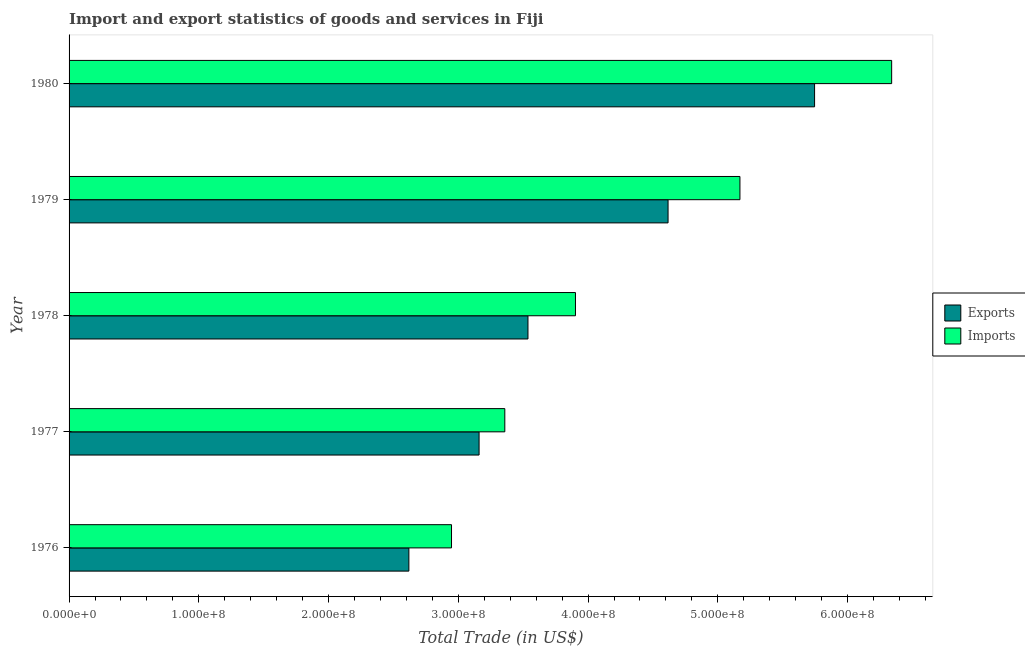How many different coloured bars are there?
Ensure brevity in your answer.  2. Are the number of bars on each tick of the Y-axis equal?
Provide a short and direct response. Yes. How many bars are there on the 5th tick from the top?
Your answer should be very brief. 2. How many bars are there on the 1st tick from the bottom?
Provide a short and direct response. 2. What is the label of the 3rd group of bars from the top?
Give a very brief answer. 1978. In how many cases, is the number of bars for a given year not equal to the number of legend labels?
Make the answer very short. 0. What is the imports of goods and services in 1978?
Your answer should be very brief. 3.90e+08. Across all years, what is the maximum export of goods and services?
Ensure brevity in your answer.  5.75e+08. Across all years, what is the minimum export of goods and services?
Offer a terse response. 2.62e+08. In which year was the export of goods and services maximum?
Offer a very short reply. 1980. In which year was the export of goods and services minimum?
Offer a very short reply. 1976. What is the total export of goods and services in the graph?
Provide a short and direct response. 1.97e+09. What is the difference between the export of goods and services in 1976 and that in 1980?
Your answer should be compact. -3.13e+08. What is the difference between the export of goods and services in 1979 and the imports of goods and services in 1980?
Give a very brief answer. -1.72e+08. What is the average export of goods and services per year?
Keep it short and to the point. 3.94e+08. In the year 1976, what is the difference between the export of goods and services and imports of goods and services?
Your answer should be very brief. -3.29e+07. What is the ratio of the export of goods and services in 1978 to that in 1980?
Your response must be concise. 0.62. Is the difference between the imports of goods and services in 1978 and 1979 greater than the difference between the export of goods and services in 1978 and 1979?
Your answer should be very brief. No. What is the difference between the highest and the second highest imports of goods and services?
Make the answer very short. 1.17e+08. What is the difference between the highest and the lowest export of goods and services?
Provide a succinct answer. 3.13e+08. In how many years, is the export of goods and services greater than the average export of goods and services taken over all years?
Provide a succinct answer. 2. Is the sum of the export of goods and services in 1976 and 1979 greater than the maximum imports of goods and services across all years?
Your response must be concise. Yes. What does the 1st bar from the top in 1980 represents?
Ensure brevity in your answer.  Imports. What does the 2nd bar from the bottom in 1980 represents?
Your answer should be very brief. Imports. What is the difference between two consecutive major ticks on the X-axis?
Your answer should be very brief. 1.00e+08. Are the values on the major ticks of X-axis written in scientific E-notation?
Give a very brief answer. Yes. Does the graph contain any zero values?
Keep it short and to the point. No. Does the graph contain grids?
Make the answer very short. No. How many legend labels are there?
Your answer should be very brief. 2. What is the title of the graph?
Give a very brief answer. Import and export statistics of goods and services in Fiji. What is the label or title of the X-axis?
Offer a terse response. Total Trade (in US$). What is the Total Trade (in US$) of Exports in 1976?
Provide a succinct answer. 2.62e+08. What is the Total Trade (in US$) in Imports in 1976?
Your answer should be very brief. 2.95e+08. What is the Total Trade (in US$) in Exports in 1977?
Your answer should be very brief. 3.16e+08. What is the Total Trade (in US$) of Imports in 1977?
Offer a terse response. 3.36e+08. What is the Total Trade (in US$) of Exports in 1978?
Your answer should be very brief. 3.54e+08. What is the Total Trade (in US$) in Imports in 1978?
Your response must be concise. 3.90e+08. What is the Total Trade (in US$) in Exports in 1979?
Your response must be concise. 4.62e+08. What is the Total Trade (in US$) in Imports in 1979?
Give a very brief answer. 5.17e+08. What is the Total Trade (in US$) in Exports in 1980?
Offer a very short reply. 5.75e+08. What is the Total Trade (in US$) in Imports in 1980?
Your response must be concise. 6.34e+08. Across all years, what is the maximum Total Trade (in US$) in Exports?
Keep it short and to the point. 5.75e+08. Across all years, what is the maximum Total Trade (in US$) of Imports?
Your answer should be compact. 6.34e+08. Across all years, what is the minimum Total Trade (in US$) of Exports?
Offer a terse response. 2.62e+08. Across all years, what is the minimum Total Trade (in US$) in Imports?
Provide a succinct answer. 2.95e+08. What is the total Total Trade (in US$) of Exports in the graph?
Provide a short and direct response. 1.97e+09. What is the total Total Trade (in US$) in Imports in the graph?
Your answer should be very brief. 2.17e+09. What is the difference between the Total Trade (in US$) of Exports in 1976 and that in 1977?
Your response must be concise. -5.41e+07. What is the difference between the Total Trade (in US$) in Imports in 1976 and that in 1977?
Give a very brief answer. -4.11e+07. What is the difference between the Total Trade (in US$) of Exports in 1976 and that in 1978?
Ensure brevity in your answer.  -9.18e+07. What is the difference between the Total Trade (in US$) in Imports in 1976 and that in 1978?
Provide a succinct answer. -9.55e+07. What is the difference between the Total Trade (in US$) in Exports in 1976 and that in 1979?
Give a very brief answer. -2.00e+08. What is the difference between the Total Trade (in US$) of Imports in 1976 and that in 1979?
Keep it short and to the point. -2.22e+08. What is the difference between the Total Trade (in US$) in Exports in 1976 and that in 1980?
Keep it short and to the point. -3.13e+08. What is the difference between the Total Trade (in US$) of Imports in 1976 and that in 1980?
Give a very brief answer. -3.39e+08. What is the difference between the Total Trade (in US$) of Exports in 1977 and that in 1978?
Keep it short and to the point. -3.77e+07. What is the difference between the Total Trade (in US$) in Imports in 1977 and that in 1978?
Ensure brevity in your answer.  -5.45e+07. What is the difference between the Total Trade (in US$) in Exports in 1977 and that in 1979?
Provide a short and direct response. -1.46e+08. What is the difference between the Total Trade (in US$) of Imports in 1977 and that in 1979?
Keep it short and to the point. -1.81e+08. What is the difference between the Total Trade (in US$) in Exports in 1977 and that in 1980?
Provide a short and direct response. -2.59e+08. What is the difference between the Total Trade (in US$) of Imports in 1977 and that in 1980?
Your response must be concise. -2.98e+08. What is the difference between the Total Trade (in US$) in Exports in 1978 and that in 1979?
Offer a very short reply. -1.08e+08. What is the difference between the Total Trade (in US$) of Imports in 1978 and that in 1979?
Give a very brief answer. -1.27e+08. What is the difference between the Total Trade (in US$) in Exports in 1978 and that in 1980?
Provide a succinct answer. -2.21e+08. What is the difference between the Total Trade (in US$) of Imports in 1978 and that in 1980?
Your response must be concise. -2.44e+08. What is the difference between the Total Trade (in US$) in Exports in 1979 and that in 1980?
Provide a succinct answer. -1.13e+08. What is the difference between the Total Trade (in US$) in Imports in 1979 and that in 1980?
Provide a succinct answer. -1.17e+08. What is the difference between the Total Trade (in US$) in Exports in 1976 and the Total Trade (in US$) in Imports in 1977?
Keep it short and to the point. -7.39e+07. What is the difference between the Total Trade (in US$) of Exports in 1976 and the Total Trade (in US$) of Imports in 1978?
Your answer should be compact. -1.28e+08. What is the difference between the Total Trade (in US$) of Exports in 1976 and the Total Trade (in US$) of Imports in 1979?
Provide a short and direct response. -2.55e+08. What is the difference between the Total Trade (in US$) of Exports in 1976 and the Total Trade (in US$) of Imports in 1980?
Your response must be concise. -3.72e+08. What is the difference between the Total Trade (in US$) of Exports in 1977 and the Total Trade (in US$) of Imports in 1978?
Your response must be concise. -7.43e+07. What is the difference between the Total Trade (in US$) in Exports in 1977 and the Total Trade (in US$) in Imports in 1979?
Your answer should be very brief. -2.01e+08. What is the difference between the Total Trade (in US$) of Exports in 1977 and the Total Trade (in US$) of Imports in 1980?
Your answer should be compact. -3.18e+08. What is the difference between the Total Trade (in US$) in Exports in 1978 and the Total Trade (in US$) in Imports in 1979?
Offer a terse response. -1.63e+08. What is the difference between the Total Trade (in US$) of Exports in 1978 and the Total Trade (in US$) of Imports in 1980?
Make the answer very short. -2.80e+08. What is the difference between the Total Trade (in US$) of Exports in 1979 and the Total Trade (in US$) of Imports in 1980?
Keep it short and to the point. -1.72e+08. What is the average Total Trade (in US$) of Exports per year?
Your answer should be very brief. 3.94e+08. What is the average Total Trade (in US$) in Imports per year?
Provide a short and direct response. 4.34e+08. In the year 1976, what is the difference between the Total Trade (in US$) of Exports and Total Trade (in US$) of Imports?
Give a very brief answer. -3.29e+07. In the year 1977, what is the difference between the Total Trade (in US$) in Exports and Total Trade (in US$) in Imports?
Ensure brevity in your answer.  -1.98e+07. In the year 1978, what is the difference between the Total Trade (in US$) in Exports and Total Trade (in US$) in Imports?
Make the answer very short. -3.66e+07. In the year 1979, what is the difference between the Total Trade (in US$) in Exports and Total Trade (in US$) in Imports?
Your answer should be very brief. -5.54e+07. In the year 1980, what is the difference between the Total Trade (in US$) of Exports and Total Trade (in US$) of Imports?
Keep it short and to the point. -5.94e+07. What is the ratio of the Total Trade (in US$) of Exports in 1976 to that in 1977?
Make the answer very short. 0.83. What is the ratio of the Total Trade (in US$) of Imports in 1976 to that in 1977?
Ensure brevity in your answer.  0.88. What is the ratio of the Total Trade (in US$) of Exports in 1976 to that in 1978?
Keep it short and to the point. 0.74. What is the ratio of the Total Trade (in US$) in Imports in 1976 to that in 1978?
Provide a short and direct response. 0.76. What is the ratio of the Total Trade (in US$) in Exports in 1976 to that in 1979?
Offer a very short reply. 0.57. What is the ratio of the Total Trade (in US$) of Imports in 1976 to that in 1979?
Make the answer very short. 0.57. What is the ratio of the Total Trade (in US$) of Exports in 1976 to that in 1980?
Keep it short and to the point. 0.46. What is the ratio of the Total Trade (in US$) of Imports in 1976 to that in 1980?
Your answer should be very brief. 0.46. What is the ratio of the Total Trade (in US$) of Exports in 1977 to that in 1978?
Make the answer very short. 0.89. What is the ratio of the Total Trade (in US$) of Imports in 1977 to that in 1978?
Give a very brief answer. 0.86. What is the ratio of the Total Trade (in US$) of Exports in 1977 to that in 1979?
Offer a very short reply. 0.68. What is the ratio of the Total Trade (in US$) of Imports in 1977 to that in 1979?
Make the answer very short. 0.65. What is the ratio of the Total Trade (in US$) in Exports in 1977 to that in 1980?
Your answer should be very brief. 0.55. What is the ratio of the Total Trade (in US$) in Imports in 1977 to that in 1980?
Offer a very short reply. 0.53. What is the ratio of the Total Trade (in US$) of Exports in 1978 to that in 1979?
Give a very brief answer. 0.77. What is the ratio of the Total Trade (in US$) of Imports in 1978 to that in 1979?
Provide a succinct answer. 0.75. What is the ratio of the Total Trade (in US$) of Exports in 1978 to that in 1980?
Make the answer very short. 0.62. What is the ratio of the Total Trade (in US$) of Imports in 1978 to that in 1980?
Offer a very short reply. 0.62. What is the ratio of the Total Trade (in US$) in Exports in 1979 to that in 1980?
Ensure brevity in your answer.  0.8. What is the ratio of the Total Trade (in US$) of Imports in 1979 to that in 1980?
Offer a terse response. 0.82. What is the difference between the highest and the second highest Total Trade (in US$) of Exports?
Your answer should be compact. 1.13e+08. What is the difference between the highest and the second highest Total Trade (in US$) in Imports?
Provide a short and direct response. 1.17e+08. What is the difference between the highest and the lowest Total Trade (in US$) of Exports?
Your response must be concise. 3.13e+08. What is the difference between the highest and the lowest Total Trade (in US$) in Imports?
Ensure brevity in your answer.  3.39e+08. 